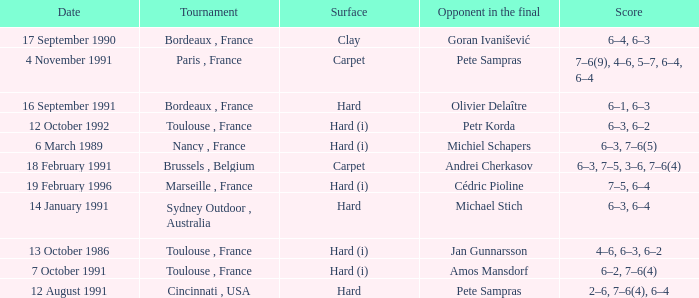I'm looking to parse the entire table for insights. Could you assist me with that? {'header': ['Date', 'Tournament', 'Surface', 'Opponent in the final', 'Score'], 'rows': [['17 September 1990', 'Bordeaux , France', 'Clay', 'Goran Ivanišević', '6–4, 6–3'], ['4 November 1991', 'Paris , France', 'Carpet', 'Pete Sampras', '7–6(9), 4–6, 5–7, 6–4, 6–4'], ['16 September 1991', 'Bordeaux , France', 'Hard', 'Olivier Delaître', '6–1, 6–3'], ['12 October 1992', 'Toulouse , France', 'Hard (i)', 'Petr Korda', '6–3, 6–2'], ['6 March 1989', 'Nancy , France', 'Hard (i)', 'Michiel Schapers', '6–3, 7–6(5)'], ['18 February 1991', 'Brussels , Belgium', 'Carpet', 'Andrei Cherkasov', '6–3, 7–5, 3–6, 7–6(4)'], ['19 February 1996', 'Marseille , France', 'Hard (i)', 'Cédric Pioline', '7–5, 6–4'], ['14 January 1991', 'Sydney Outdoor , Australia', 'Hard', 'Michael Stich', '6–3, 6–4'], ['13 October 1986', 'Toulouse , France', 'Hard (i)', 'Jan Gunnarsson', '4–6, 6–3, 6–2'], ['7 October 1991', 'Toulouse , France', 'Hard (i)', 'Amos Mansdorf', '6–2, 7–6(4)'], ['12 August 1991', 'Cincinnati , USA', 'Hard', 'Pete Sampras', '2–6, 7–6(4), 6–4']]} What is the score of the tournament with olivier delaître as the opponent in the final? 6–1, 6–3. 